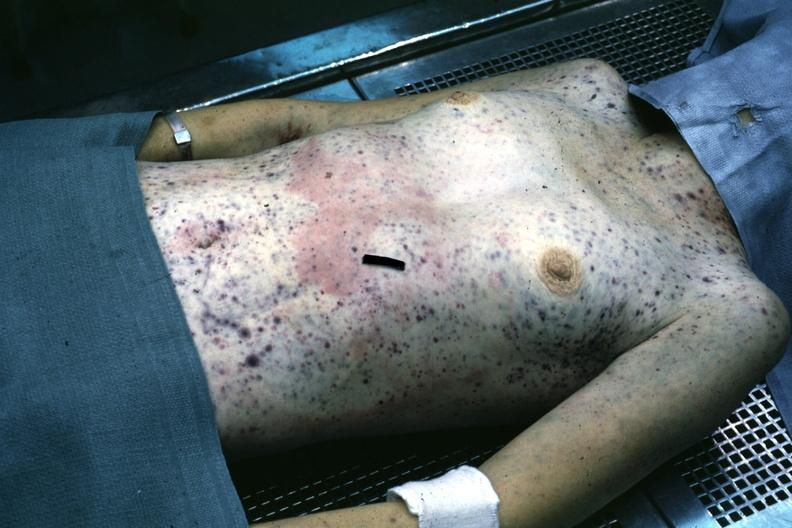where is this?
Answer the question using a single word or phrase. Skin 